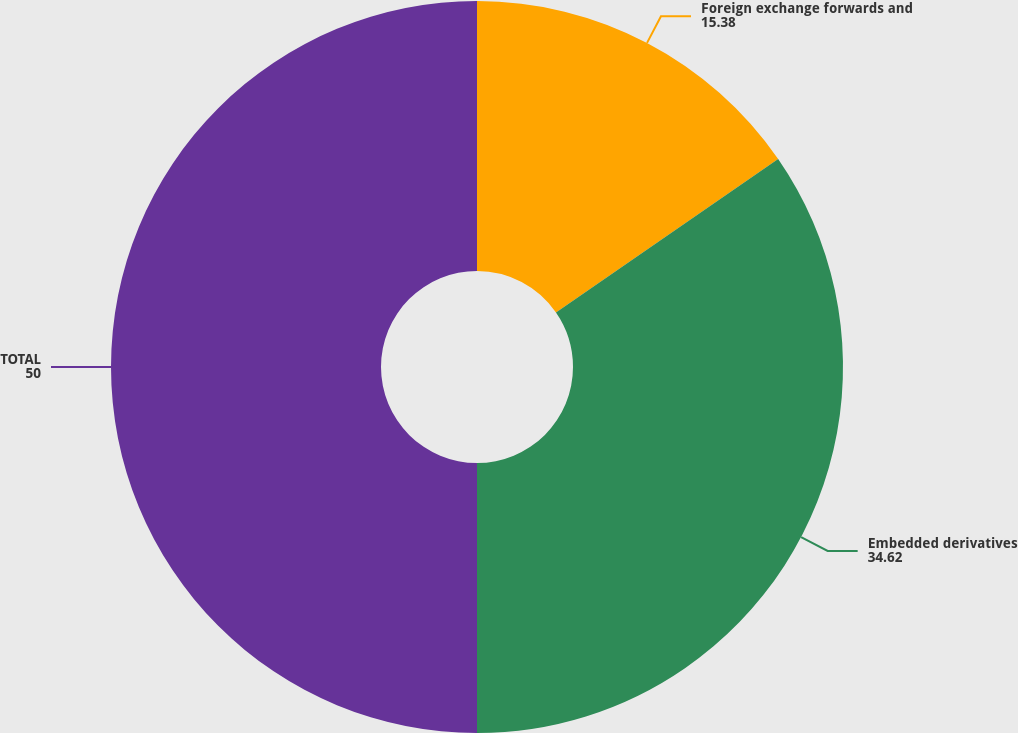Convert chart. <chart><loc_0><loc_0><loc_500><loc_500><pie_chart><fcel>Foreign exchange forwards and<fcel>Embedded derivatives<fcel>TOTAL<nl><fcel>15.38%<fcel>34.62%<fcel>50.0%<nl></chart> 